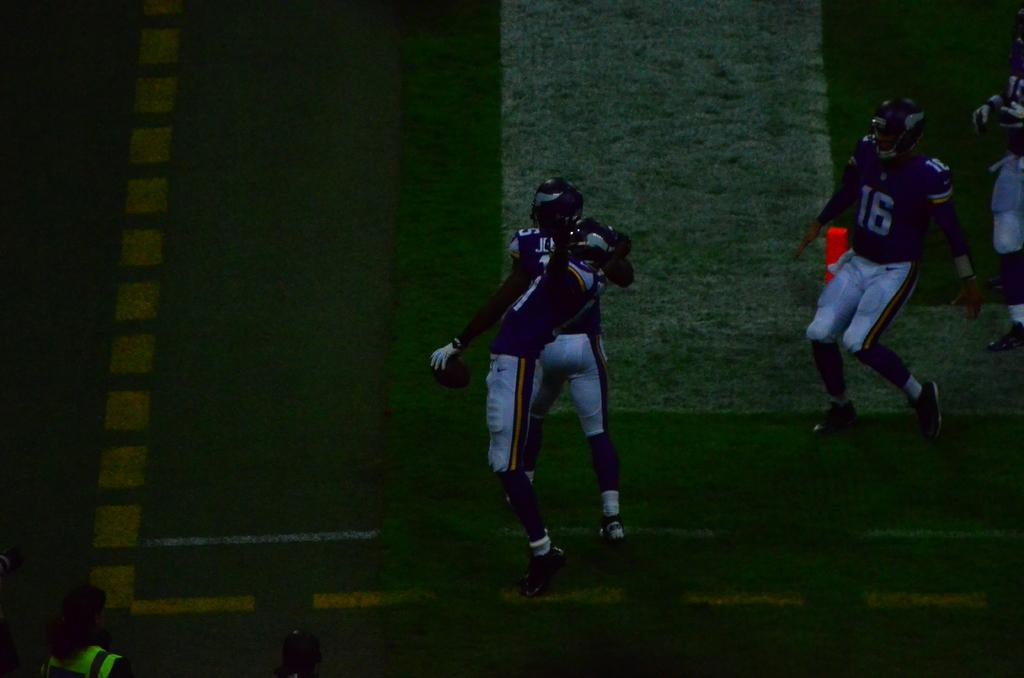What can be seen in the image? There are people standing in the image. Where are the people standing? The people are standing on the ground. What is the ground covered with? There is grass on the ground. What are the people wearing on their heads? The people are wearing helmets. How many passengers are visible in the image? There is no mention of passengers in the image. 